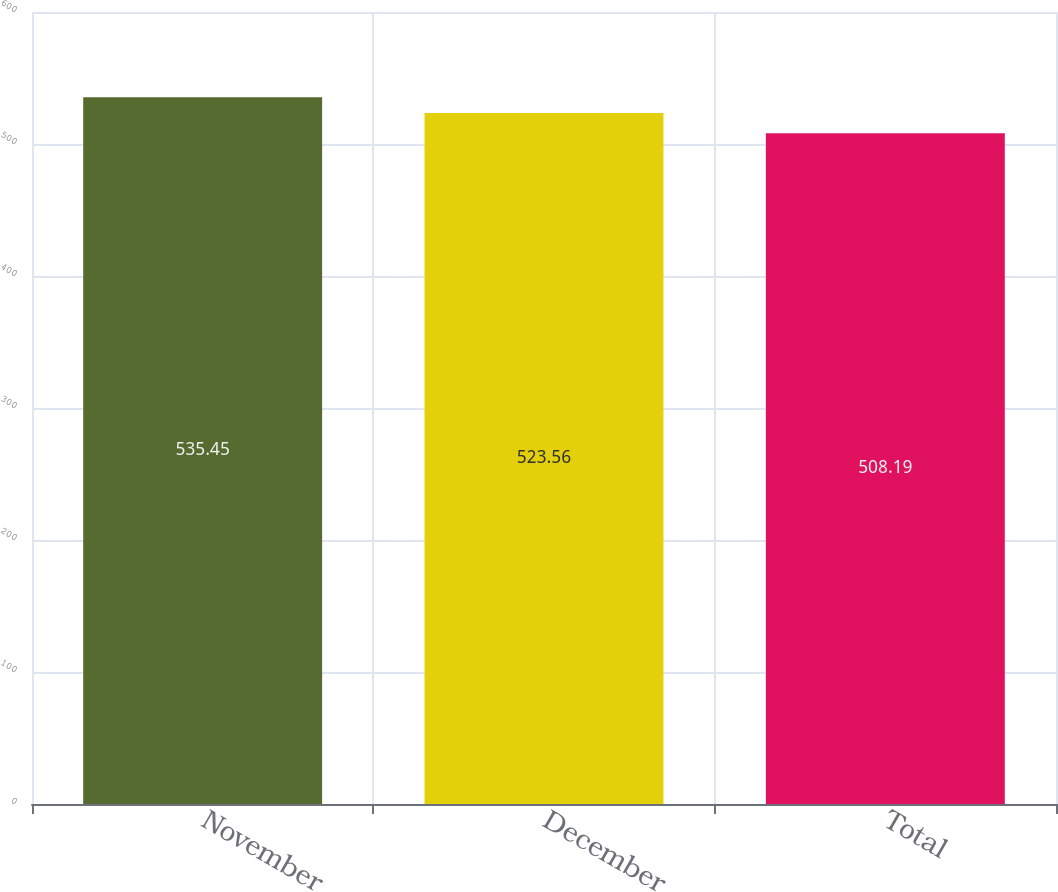<chart> <loc_0><loc_0><loc_500><loc_500><bar_chart><fcel>November<fcel>December<fcel>Total<nl><fcel>535.45<fcel>523.56<fcel>508.19<nl></chart> 